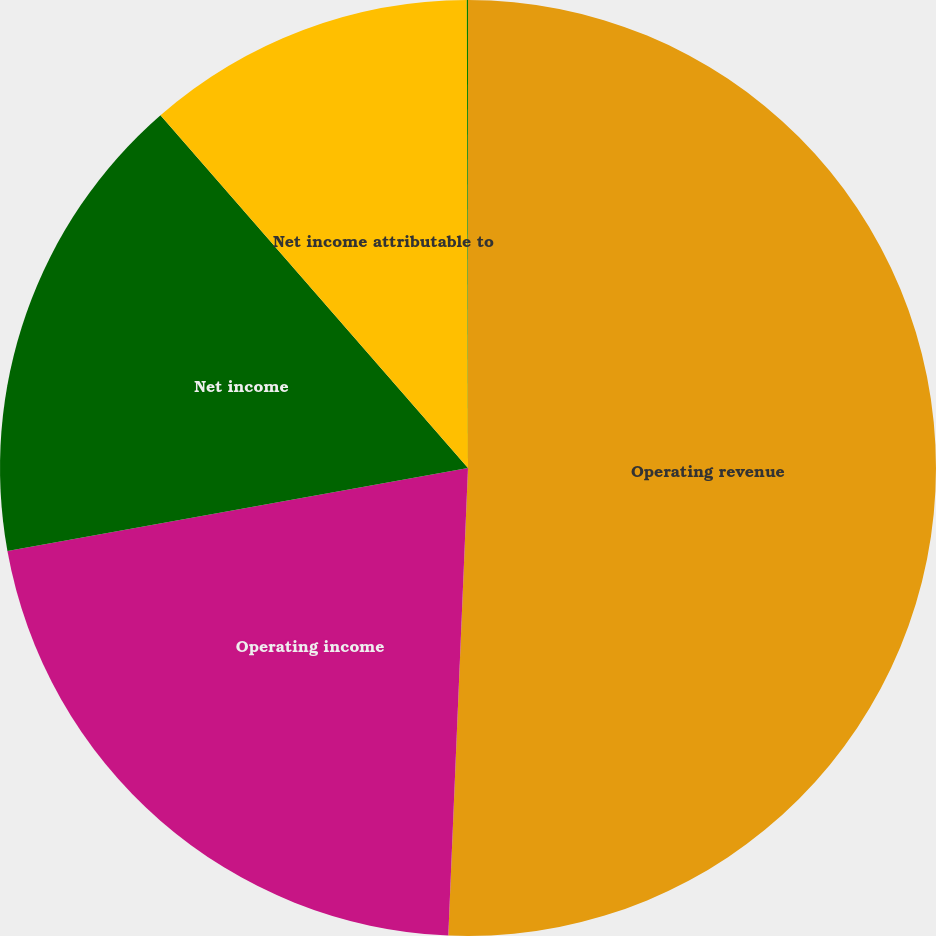<chart> <loc_0><loc_0><loc_500><loc_500><pie_chart><fcel>Operating revenue<fcel>Operating income<fcel>Net income<fcel>Net income attributable to<fcel>Basic and diluted earnings per<nl><fcel>50.67%<fcel>21.49%<fcel>16.43%<fcel>11.37%<fcel>0.04%<nl></chart> 